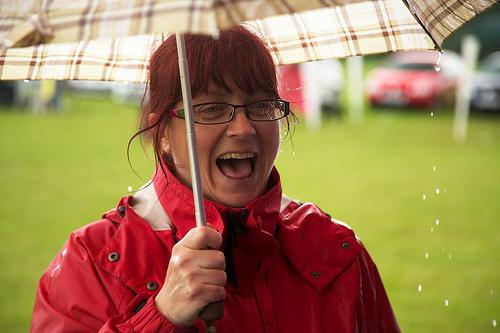Question: what is the woman holding in her right hand?
Choices:
A. Umbrella.
B. A stroller.
C. A bag.
D. Her jacket.
Answer with the letter. Answer: A Question: who is behind the woman?
Choices:
A. No one.
B. The building.
C. Her son.
D. A street corner.
Answer with the letter. Answer: A Question: what pattern is the umbrella?
Choices:
A. Solid black.
B. Plaid.
C. Striped.
D. Wavy lines.
Answer with the letter. Answer: B Question: what is the woman wearing on her eyes?
Choices:
A. Sunglasses.
B. A hat.
C. Glasses.
D. A helmet.
Answer with the letter. Answer: C 